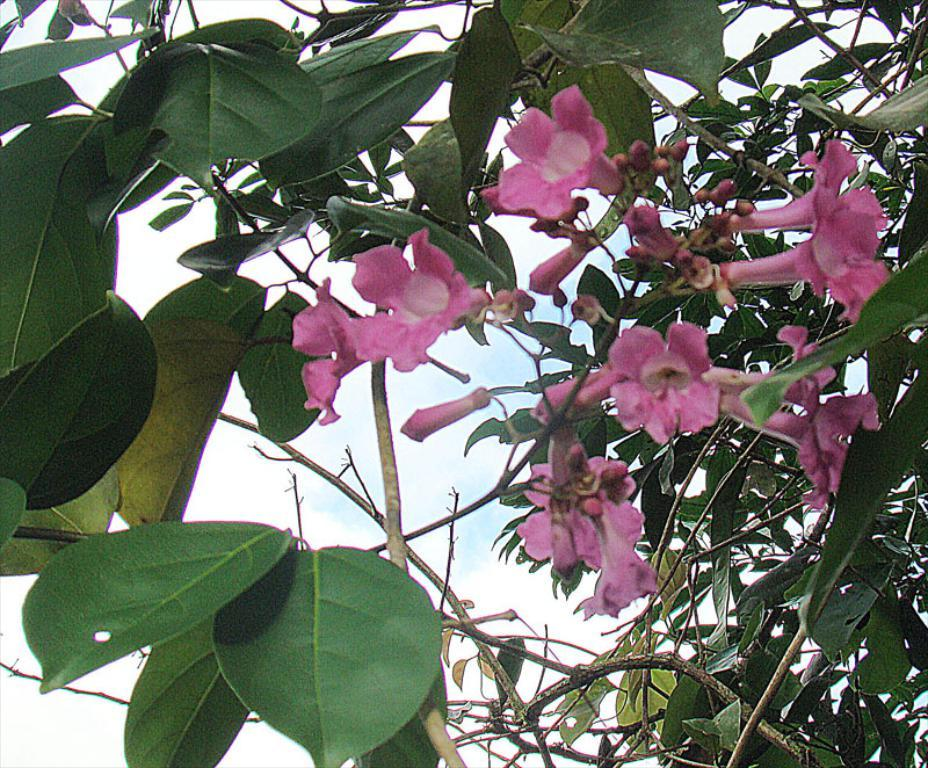What is in the foreground of the image? There are flowers in the foreground of the image. What can be observed on the stems of the flowers? There are leaves on the stems in the foreground of the image. What is visible in the background of the image? The sky is visible in the background of the image. How many forks can be seen in the image? There are no forks present in the image. What type of burn can be observed in the image? There is no burn present in the image. 